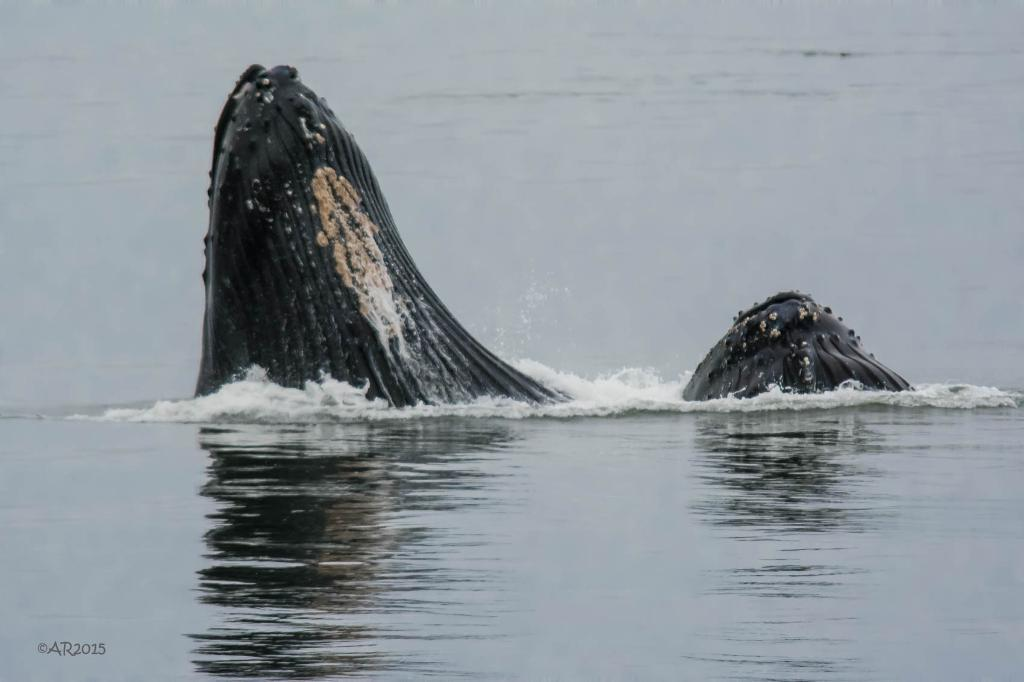What is present in the image? There is water visible in the image. Can you describe anything within the water? There is an unspecified object or feature in the water. Where is your uncle in the image? There is no mention of an uncle in the image, as the facts only mention water and an unspecified object or feature in the water. 